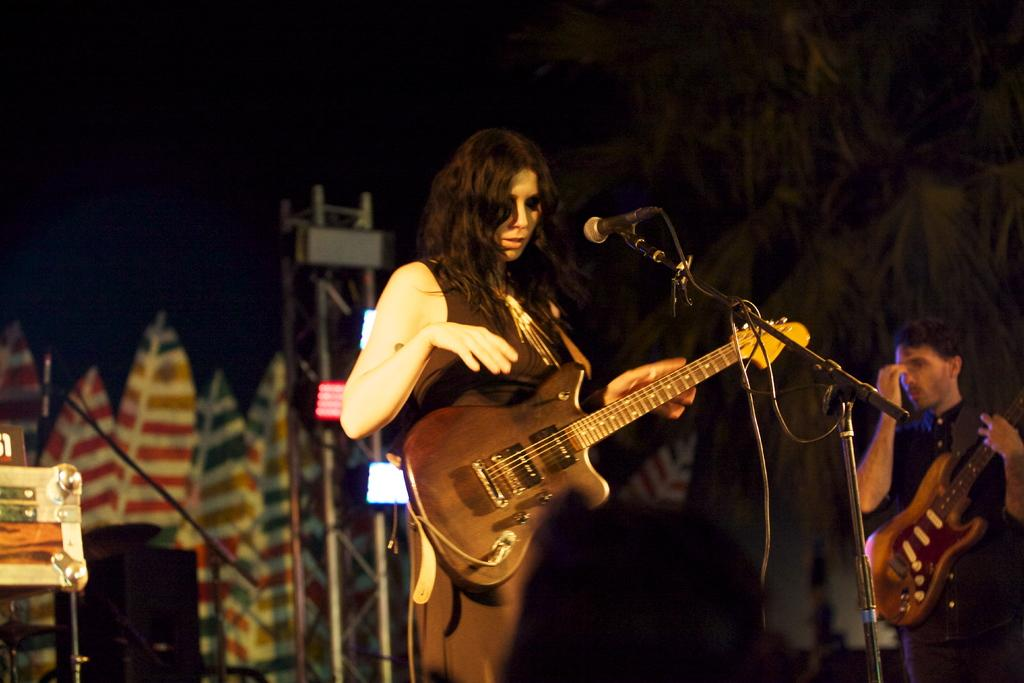What is the woman in the image doing? The woman is playing a guitar. What is the woman wearing? The woman is wearing a brown dress. How is the woman's hair styled? The woman has loose hair. What is the woman positioned in front of? The woman is in front of a microphone. Can you describe the man in the image? There is a man at a distance holding a guitar. What is the lighting condition in the image? The background of the image is dark. What type of ink can be seen on the woman's dress in the image? There is no ink visible on the woman's dress in the image. What day of the week is the woman performing on in the image? The day of the week is not mentioned or depicted in the image. 